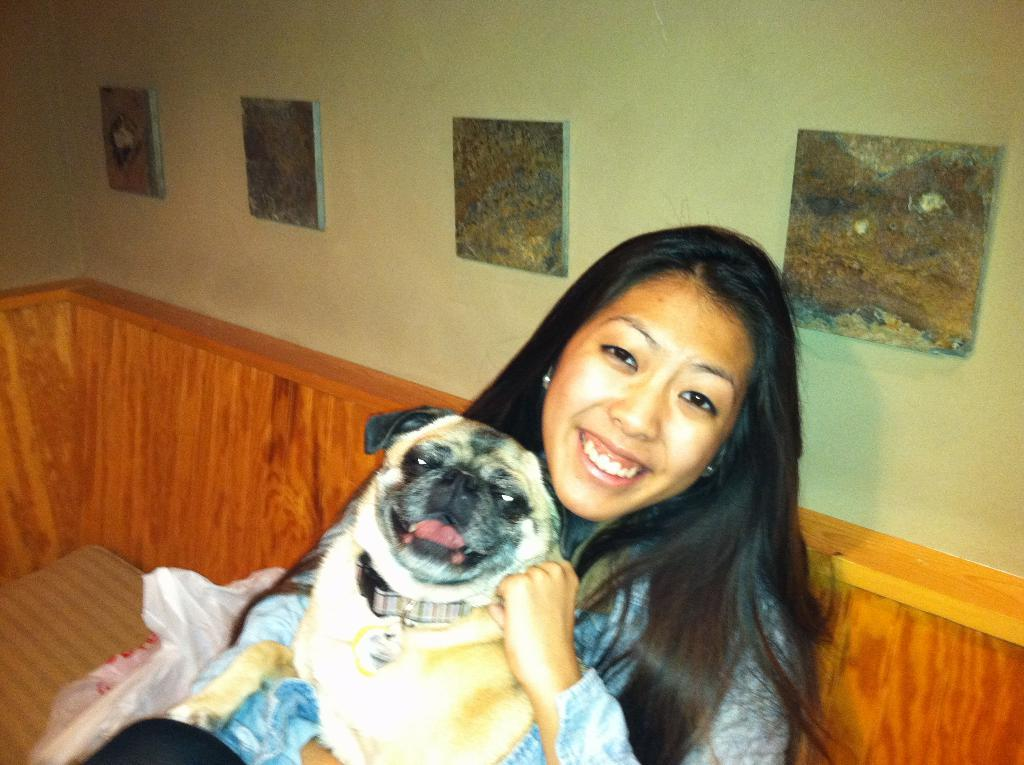Who is the main subject in the image? There is a woman in the image. What is the woman doing in the image? The woman is holding a pug dog in her lap. What news is the woman reading in the image? There is no news or any reading material visible in the image. 